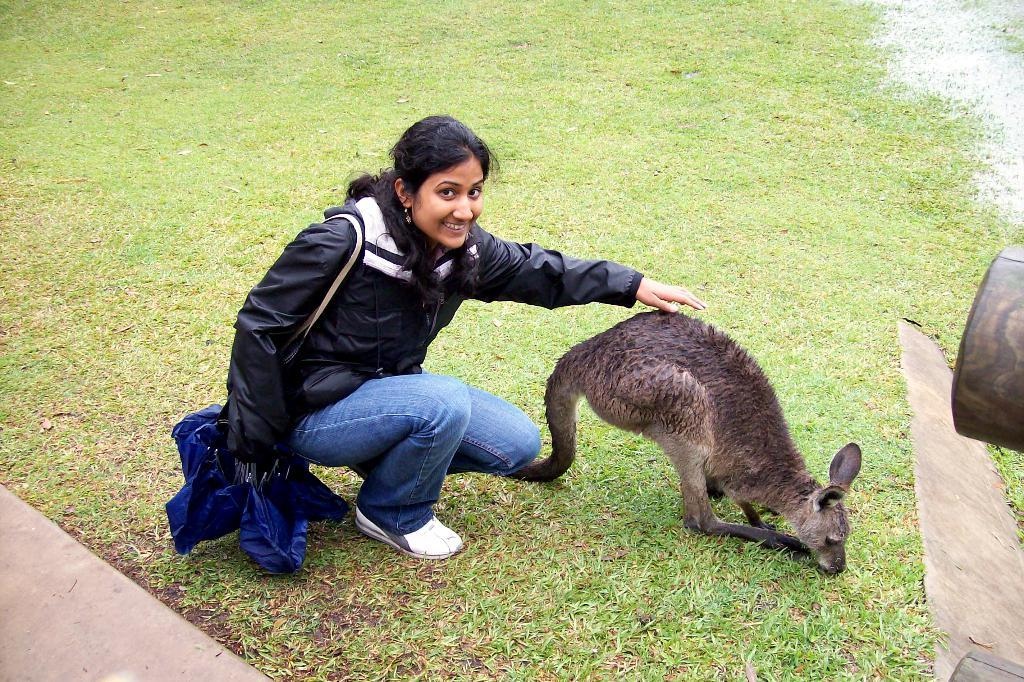Who is present in the image? There is a woman in the image. What other living creature is present in the image? There is an animal in the image. Where are the woman and the animal located? Both the woman and the animal are on the ground. What can be seen in the background of the image? The background of the image includes grass. What object is visible in the image? There is an object in the image. What type of trees are mentioned in the story depicted in the image? There is no story present in the image, and therefore no trees are mentioned. 